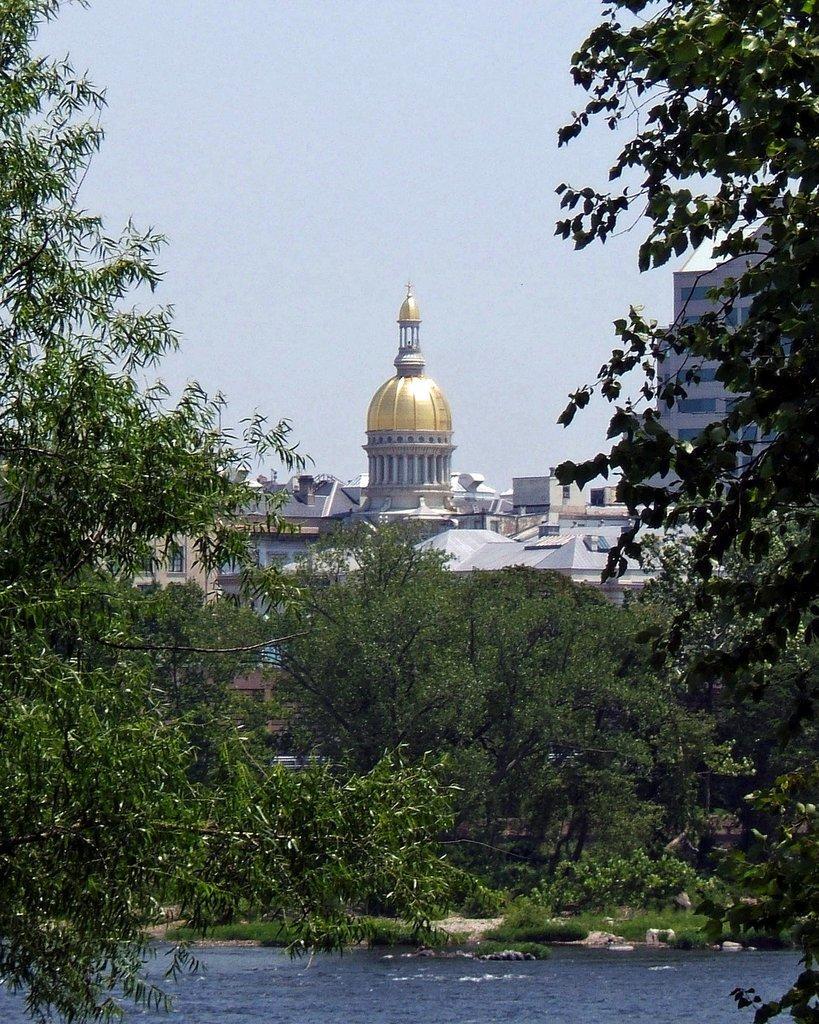In one or two sentences, can you explain what this image depicts? There is water. There are trees behind that and buildings are present at the back. 